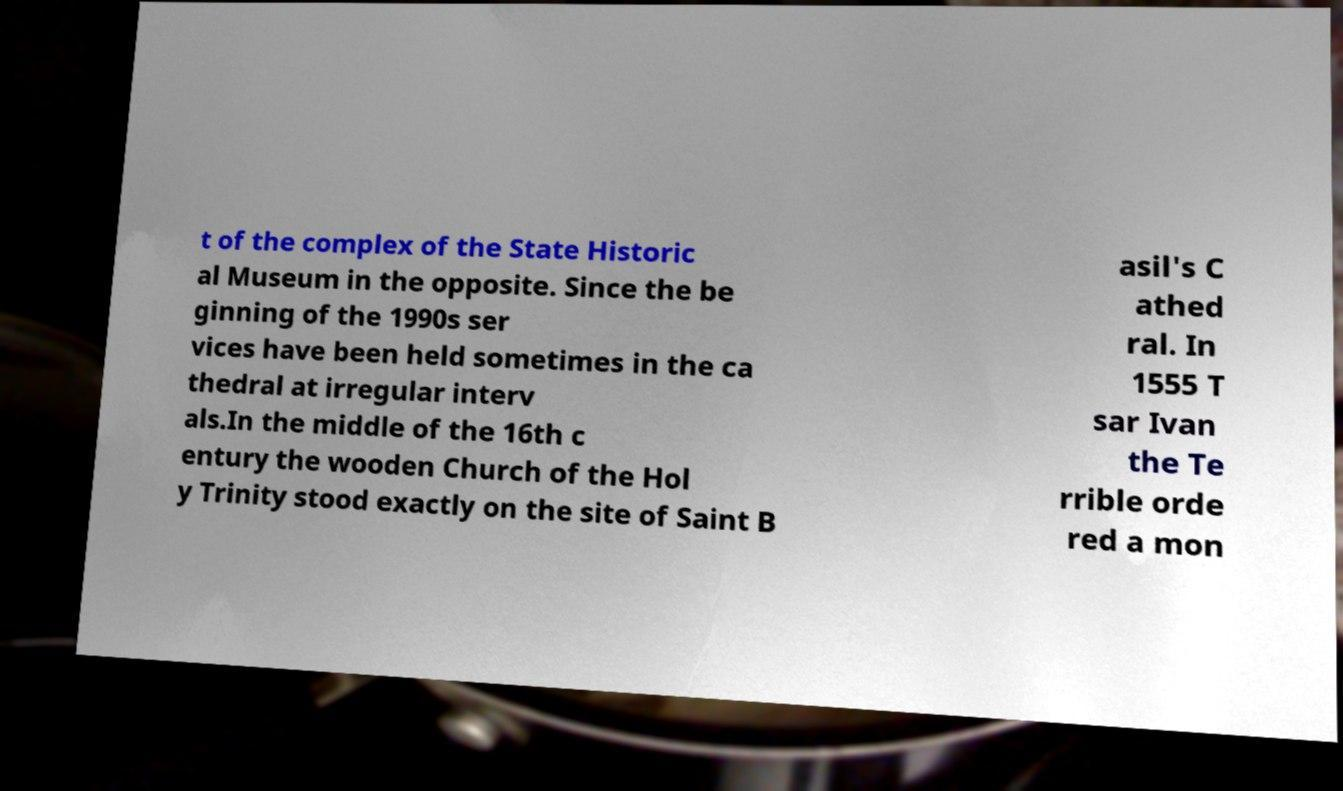Could you extract and type out the text from this image? t of the complex of the State Historic al Museum in the opposite. Since the be ginning of the 1990s ser vices have been held sometimes in the ca thedral at irregular interv als.In the middle of the 16th c entury the wooden Church of the Hol y Trinity stood exactly on the site of Saint B asil's C athed ral. In 1555 T sar Ivan the Te rrible orde red a mon 